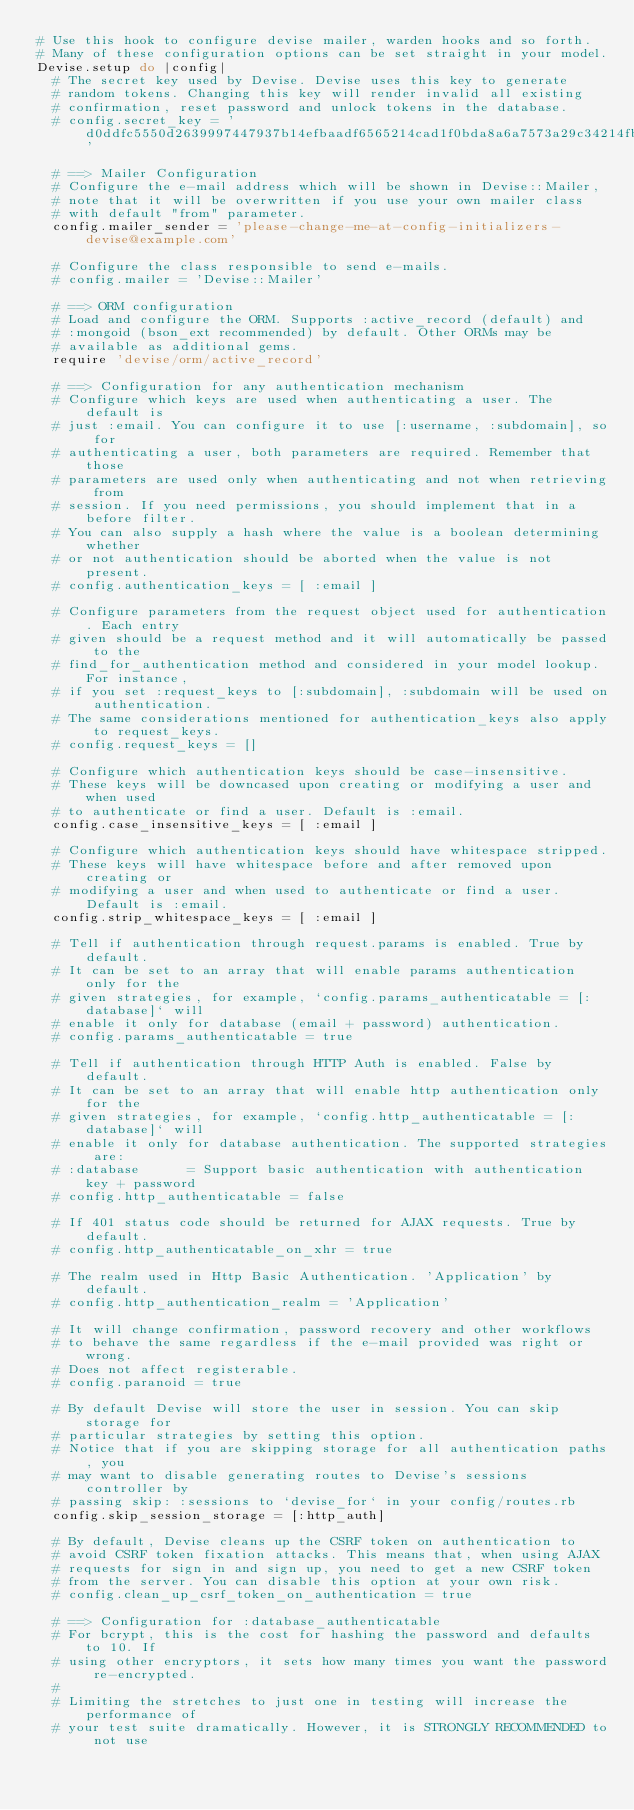Convert code to text. <code><loc_0><loc_0><loc_500><loc_500><_Ruby_># Use this hook to configure devise mailer, warden hooks and so forth.
# Many of these configuration options can be set straight in your model.
Devise.setup do |config|
  # The secret key used by Devise. Devise uses this key to generate
  # random tokens. Changing this key will render invalid all existing
  # confirmation, reset password and unlock tokens in the database.
  # config.secret_key = 'd0ddfc5550d2639997447937b14efbaadf6565214cad1f0bda8a6a7573a29c34214fb5e1384bc98ba5f6b9a36eae6bf4f4f7595aecfa31a032d09908fec1cd5c'

  # ==> Mailer Configuration
  # Configure the e-mail address which will be shown in Devise::Mailer,
  # note that it will be overwritten if you use your own mailer class
  # with default "from" parameter.
  config.mailer_sender = 'please-change-me-at-config-initializers-devise@example.com'

  # Configure the class responsible to send e-mails.
  # config.mailer = 'Devise::Mailer'

  # ==> ORM configuration
  # Load and configure the ORM. Supports :active_record (default) and
  # :mongoid (bson_ext recommended) by default. Other ORMs may be
  # available as additional gems.
  require 'devise/orm/active_record'

  # ==> Configuration for any authentication mechanism
  # Configure which keys are used when authenticating a user. The default is
  # just :email. You can configure it to use [:username, :subdomain], so for
  # authenticating a user, both parameters are required. Remember that those
  # parameters are used only when authenticating and not when retrieving from
  # session. If you need permissions, you should implement that in a before filter.
  # You can also supply a hash where the value is a boolean determining whether
  # or not authentication should be aborted when the value is not present.
  # config.authentication_keys = [ :email ]

  # Configure parameters from the request object used for authentication. Each entry
  # given should be a request method and it will automatically be passed to the
  # find_for_authentication method and considered in your model lookup. For instance,
  # if you set :request_keys to [:subdomain], :subdomain will be used on authentication.
  # The same considerations mentioned for authentication_keys also apply to request_keys.
  # config.request_keys = []

  # Configure which authentication keys should be case-insensitive.
  # These keys will be downcased upon creating or modifying a user and when used
  # to authenticate or find a user. Default is :email.
  config.case_insensitive_keys = [ :email ]

  # Configure which authentication keys should have whitespace stripped.
  # These keys will have whitespace before and after removed upon creating or
  # modifying a user and when used to authenticate or find a user. Default is :email.
  config.strip_whitespace_keys = [ :email ]

  # Tell if authentication through request.params is enabled. True by default.
  # It can be set to an array that will enable params authentication only for the
  # given strategies, for example, `config.params_authenticatable = [:database]` will
  # enable it only for database (email + password) authentication.
  # config.params_authenticatable = true

  # Tell if authentication through HTTP Auth is enabled. False by default.
  # It can be set to an array that will enable http authentication only for the
  # given strategies, for example, `config.http_authenticatable = [:database]` will
  # enable it only for database authentication. The supported strategies are:
  # :database      = Support basic authentication with authentication key + password
  # config.http_authenticatable = false

  # If 401 status code should be returned for AJAX requests. True by default.
  # config.http_authenticatable_on_xhr = true

  # The realm used in Http Basic Authentication. 'Application' by default.
  # config.http_authentication_realm = 'Application'

  # It will change confirmation, password recovery and other workflows
  # to behave the same regardless if the e-mail provided was right or wrong.
  # Does not affect registerable.
  # config.paranoid = true

  # By default Devise will store the user in session. You can skip storage for
  # particular strategies by setting this option.
  # Notice that if you are skipping storage for all authentication paths, you
  # may want to disable generating routes to Devise's sessions controller by
  # passing skip: :sessions to `devise_for` in your config/routes.rb
  config.skip_session_storage = [:http_auth]

  # By default, Devise cleans up the CSRF token on authentication to
  # avoid CSRF token fixation attacks. This means that, when using AJAX
  # requests for sign in and sign up, you need to get a new CSRF token
  # from the server. You can disable this option at your own risk.
  # config.clean_up_csrf_token_on_authentication = true

  # ==> Configuration for :database_authenticatable
  # For bcrypt, this is the cost for hashing the password and defaults to 10. If
  # using other encryptors, it sets how many times you want the password re-encrypted.
  #
  # Limiting the stretches to just one in testing will increase the performance of
  # your test suite dramatically. However, it is STRONGLY RECOMMENDED to not use</code> 